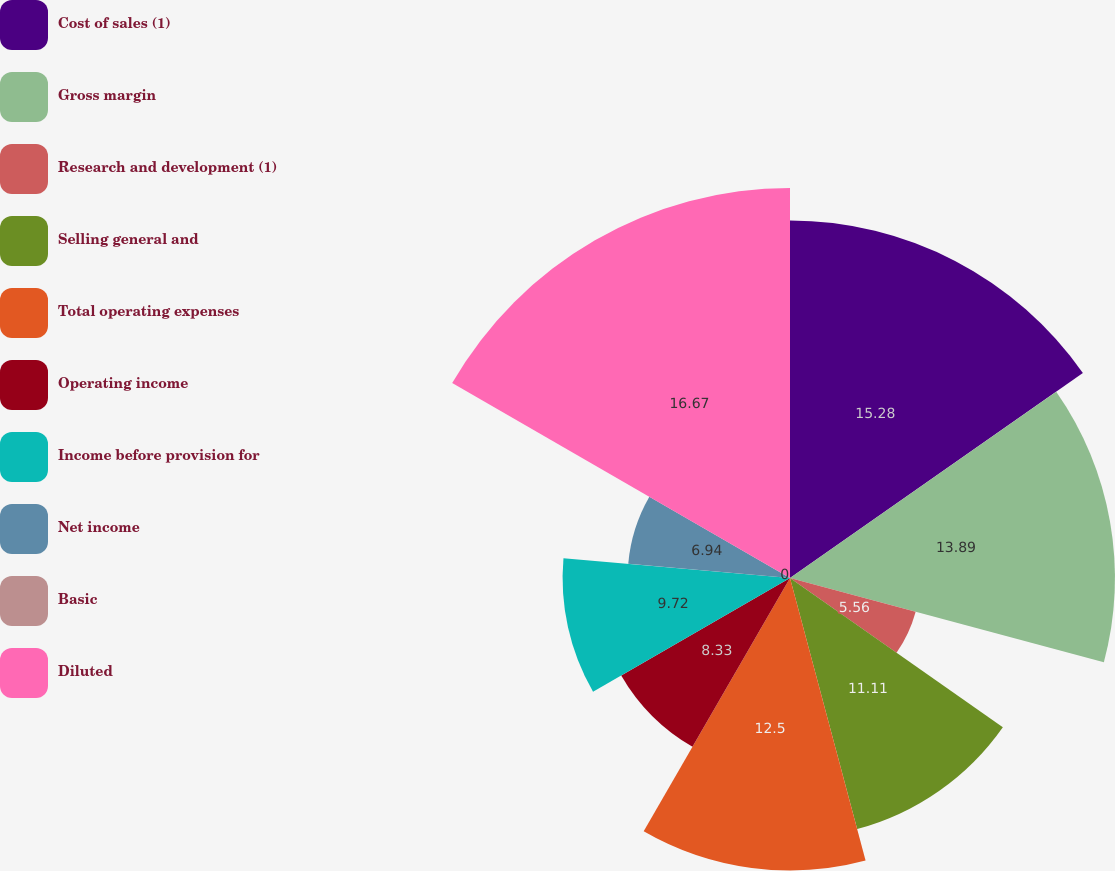Convert chart. <chart><loc_0><loc_0><loc_500><loc_500><pie_chart><fcel>Cost of sales (1)<fcel>Gross margin<fcel>Research and development (1)<fcel>Selling general and<fcel>Total operating expenses<fcel>Operating income<fcel>Income before provision for<fcel>Net income<fcel>Basic<fcel>Diluted<nl><fcel>15.28%<fcel>13.89%<fcel>5.56%<fcel>11.11%<fcel>12.5%<fcel>8.33%<fcel>9.72%<fcel>6.94%<fcel>0.0%<fcel>16.67%<nl></chart> 